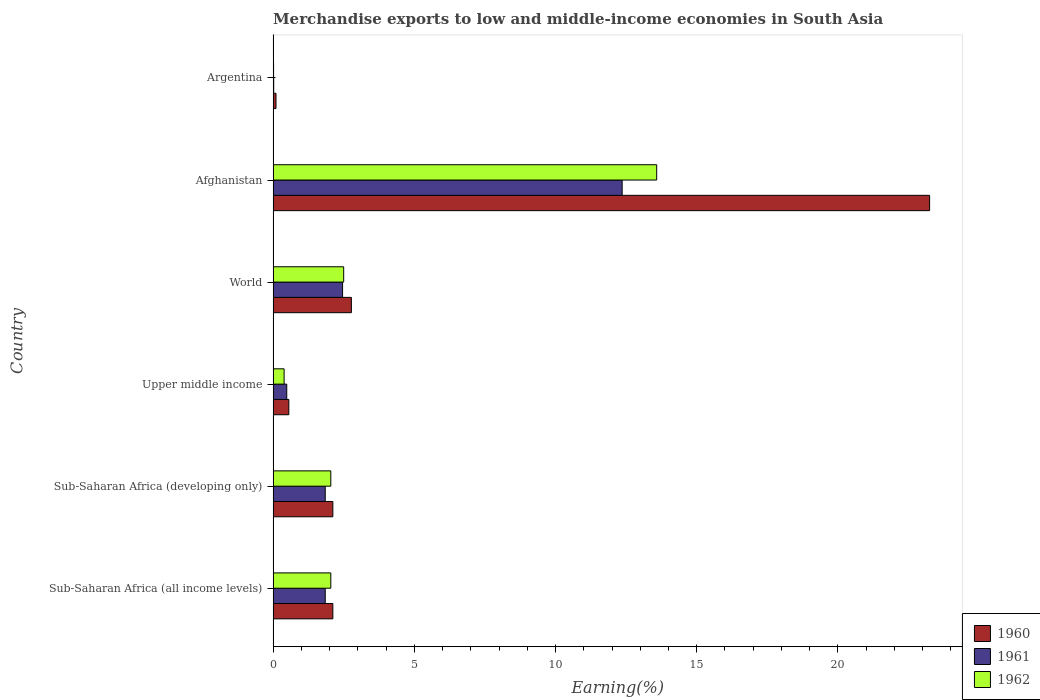How many bars are there on the 6th tick from the bottom?
Give a very brief answer. 3. In how many cases, is the number of bars for a given country not equal to the number of legend labels?
Provide a short and direct response. 0. What is the percentage of amount earned from merchandise exports in 1962 in Afghanistan?
Provide a short and direct response. 13.58. Across all countries, what is the maximum percentage of amount earned from merchandise exports in 1962?
Your answer should be compact. 13.58. Across all countries, what is the minimum percentage of amount earned from merchandise exports in 1961?
Offer a terse response. 0.02. In which country was the percentage of amount earned from merchandise exports in 1962 maximum?
Give a very brief answer. Afghanistan. What is the total percentage of amount earned from merchandise exports in 1961 in the graph?
Provide a short and direct response. 19.01. What is the difference between the percentage of amount earned from merchandise exports in 1960 in Afghanistan and that in Argentina?
Offer a terse response. 23.14. What is the difference between the percentage of amount earned from merchandise exports in 1960 in Upper middle income and the percentage of amount earned from merchandise exports in 1962 in Sub-Saharan Africa (all income levels)?
Provide a succinct answer. -1.49. What is the average percentage of amount earned from merchandise exports in 1961 per country?
Ensure brevity in your answer.  3.17. What is the difference between the percentage of amount earned from merchandise exports in 1960 and percentage of amount earned from merchandise exports in 1961 in Upper middle income?
Give a very brief answer. 0.07. What is the ratio of the percentage of amount earned from merchandise exports in 1962 in Sub-Saharan Africa (developing only) to that in World?
Keep it short and to the point. 0.82. What is the difference between the highest and the second highest percentage of amount earned from merchandise exports in 1961?
Make the answer very short. 9.9. What is the difference between the highest and the lowest percentage of amount earned from merchandise exports in 1961?
Your answer should be compact. 12.34. In how many countries, is the percentage of amount earned from merchandise exports in 1960 greater than the average percentage of amount earned from merchandise exports in 1960 taken over all countries?
Provide a succinct answer. 1. Is the sum of the percentage of amount earned from merchandise exports in 1960 in Upper middle income and World greater than the maximum percentage of amount earned from merchandise exports in 1962 across all countries?
Provide a succinct answer. No. Is it the case that in every country, the sum of the percentage of amount earned from merchandise exports in 1962 and percentage of amount earned from merchandise exports in 1960 is greater than the percentage of amount earned from merchandise exports in 1961?
Offer a very short reply. Yes. Are all the bars in the graph horizontal?
Offer a terse response. Yes. What is the difference between two consecutive major ticks on the X-axis?
Ensure brevity in your answer.  5. Where does the legend appear in the graph?
Keep it short and to the point. Bottom right. How many legend labels are there?
Your answer should be compact. 3. What is the title of the graph?
Offer a very short reply. Merchandise exports to low and middle-income economies in South Asia. What is the label or title of the X-axis?
Offer a very short reply. Earning(%). What is the label or title of the Y-axis?
Your answer should be compact. Country. What is the Earning(%) in 1960 in Sub-Saharan Africa (all income levels)?
Offer a very short reply. 2.11. What is the Earning(%) of 1961 in Sub-Saharan Africa (all income levels)?
Give a very brief answer. 1.85. What is the Earning(%) in 1962 in Sub-Saharan Africa (all income levels)?
Your answer should be very brief. 2.04. What is the Earning(%) of 1960 in Sub-Saharan Africa (developing only)?
Your response must be concise. 2.11. What is the Earning(%) in 1961 in Sub-Saharan Africa (developing only)?
Your answer should be compact. 1.85. What is the Earning(%) of 1962 in Sub-Saharan Africa (developing only)?
Keep it short and to the point. 2.04. What is the Earning(%) in 1960 in Upper middle income?
Provide a short and direct response. 0.56. What is the Earning(%) in 1961 in Upper middle income?
Make the answer very short. 0.48. What is the Earning(%) in 1962 in Upper middle income?
Offer a very short reply. 0.39. What is the Earning(%) of 1960 in World?
Ensure brevity in your answer.  2.77. What is the Earning(%) of 1961 in World?
Keep it short and to the point. 2.46. What is the Earning(%) of 1962 in World?
Your response must be concise. 2.5. What is the Earning(%) in 1960 in Afghanistan?
Your answer should be very brief. 23.25. What is the Earning(%) of 1961 in Afghanistan?
Your answer should be very brief. 12.36. What is the Earning(%) in 1962 in Afghanistan?
Ensure brevity in your answer.  13.58. What is the Earning(%) of 1960 in Argentina?
Your answer should be very brief. 0.1. What is the Earning(%) of 1961 in Argentina?
Provide a short and direct response. 0.02. What is the Earning(%) of 1962 in Argentina?
Ensure brevity in your answer.  0.02. Across all countries, what is the maximum Earning(%) of 1960?
Your response must be concise. 23.25. Across all countries, what is the maximum Earning(%) in 1961?
Your answer should be compact. 12.36. Across all countries, what is the maximum Earning(%) in 1962?
Offer a terse response. 13.58. Across all countries, what is the minimum Earning(%) of 1960?
Provide a short and direct response. 0.1. Across all countries, what is the minimum Earning(%) of 1961?
Provide a short and direct response. 0.02. Across all countries, what is the minimum Earning(%) of 1962?
Provide a succinct answer. 0.02. What is the total Earning(%) in 1960 in the graph?
Provide a short and direct response. 30.91. What is the total Earning(%) in 1961 in the graph?
Provide a succinct answer. 19.01. What is the total Earning(%) in 1962 in the graph?
Your answer should be compact. 20.57. What is the difference between the Earning(%) in 1960 in Sub-Saharan Africa (all income levels) and that in Upper middle income?
Provide a short and direct response. 1.56. What is the difference between the Earning(%) of 1961 in Sub-Saharan Africa (all income levels) and that in Upper middle income?
Your answer should be very brief. 1.36. What is the difference between the Earning(%) in 1962 in Sub-Saharan Africa (all income levels) and that in Upper middle income?
Offer a very short reply. 1.65. What is the difference between the Earning(%) in 1960 in Sub-Saharan Africa (all income levels) and that in World?
Make the answer very short. -0.66. What is the difference between the Earning(%) in 1961 in Sub-Saharan Africa (all income levels) and that in World?
Your response must be concise. -0.61. What is the difference between the Earning(%) in 1962 in Sub-Saharan Africa (all income levels) and that in World?
Give a very brief answer. -0.46. What is the difference between the Earning(%) in 1960 in Sub-Saharan Africa (all income levels) and that in Afghanistan?
Give a very brief answer. -21.13. What is the difference between the Earning(%) in 1961 in Sub-Saharan Africa (all income levels) and that in Afghanistan?
Make the answer very short. -10.51. What is the difference between the Earning(%) of 1962 in Sub-Saharan Africa (all income levels) and that in Afghanistan?
Offer a very short reply. -11.54. What is the difference between the Earning(%) in 1960 in Sub-Saharan Africa (all income levels) and that in Argentina?
Your answer should be compact. 2.01. What is the difference between the Earning(%) of 1961 in Sub-Saharan Africa (all income levels) and that in Argentina?
Ensure brevity in your answer.  1.82. What is the difference between the Earning(%) in 1962 in Sub-Saharan Africa (all income levels) and that in Argentina?
Offer a terse response. 2.03. What is the difference between the Earning(%) of 1960 in Sub-Saharan Africa (developing only) and that in Upper middle income?
Offer a terse response. 1.56. What is the difference between the Earning(%) of 1961 in Sub-Saharan Africa (developing only) and that in Upper middle income?
Keep it short and to the point. 1.36. What is the difference between the Earning(%) of 1962 in Sub-Saharan Africa (developing only) and that in Upper middle income?
Provide a short and direct response. 1.65. What is the difference between the Earning(%) of 1960 in Sub-Saharan Africa (developing only) and that in World?
Provide a succinct answer. -0.66. What is the difference between the Earning(%) of 1961 in Sub-Saharan Africa (developing only) and that in World?
Give a very brief answer. -0.61. What is the difference between the Earning(%) of 1962 in Sub-Saharan Africa (developing only) and that in World?
Your answer should be compact. -0.46. What is the difference between the Earning(%) in 1960 in Sub-Saharan Africa (developing only) and that in Afghanistan?
Offer a very short reply. -21.13. What is the difference between the Earning(%) of 1961 in Sub-Saharan Africa (developing only) and that in Afghanistan?
Your response must be concise. -10.51. What is the difference between the Earning(%) of 1962 in Sub-Saharan Africa (developing only) and that in Afghanistan?
Provide a succinct answer. -11.54. What is the difference between the Earning(%) in 1960 in Sub-Saharan Africa (developing only) and that in Argentina?
Offer a terse response. 2.01. What is the difference between the Earning(%) of 1961 in Sub-Saharan Africa (developing only) and that in Argentina?
Your answer should be very brief. 1.82. What is the difference between the Earning(%) in 1962 in Sub-Saharan Africa (developing only) and that in Argentina?
Offer a very short reply. 2.03. What is the difference between the Earning(%) in 1960 in Upper middle income and that in World?
Your answer should be compact. -2.21. What is the difference between the Earning(%) in 1961 in Upper middle income and that in World?
Your response must be concise. -1.98. What is the difference between the Earning(%) in 1962 in Upper middle income and that in World?
Your answer should be compact. -2.11. What is the difference between the Earning(%) of 1960 in Upper middle income and that in Afghanistan?
Give a very brief answer. -22.69. What is the difference between the Earning(%) of 1961 in Upper middle income and that in Afghanistan?
Provide a short and direct response. -11.88. What is the difference between the Earning(%) in 1962 in Upper middle income and that in Afghanistan?
Provide a short and direct response. -13.19. What is the difference between the Earning(%) in 1960 in Upper middle income and that in Argentina?
Your answer should be very brief. 0.45. What is the difference between the Earning(%) in 1961 in Upper middle income and that in Argentina?
Make the answer very short. 0.46. What is the difference between the Earning(%) in 1962 in Upper middle income and that in Argentina?
Offer a terse response. 0.37. What is the difference between the Earning(%) in 1960 in World and that in Afghanistan?
Your answer should be very brief. -20.48. What is the difference between the Earning(%) in 1961 in World and that in Afghanistan?
Give a very brief answer. -9.9. What is the difference between the Earning(%) of 1962 in World and that in Afghanistan?
Your answer should be compact. -11.08. What is the difference between the Earning(%) in 1960 in World and that in Argentina?
Offer a very short reply. 2.67. What is the difference between the Earning(%) of 1961 in World and that in Argentina?
Your response must be concise. 2.44. What is the difference between the Earning(%) in 1962 in World and that in Argentina?
Make the answer very short. 2.48. What is the difference between the Earning(%) in 1960 in Afghanistan and that in Argentina?
Make the answer very short. 23.14. What is the difference between the Earning(%) in 1961 in Afghanistan and that in Argentina?
Your answer should be compact. 12.34. What is the difference between the Earning(%) in 1962 in Afghanistan and that in Argentina?
Your response must be concise. 13.57. What is the difference between the Earning(%) in 1960 in Sub-Saharan Africa (all income levels) and the Earning(%) in 1961 in Sub-Saharan Africa (developing only)?
Provide a short and direct response. 0.27. What is the difference between the Earning(%) in 1960 in Sub-Saharan Africa (all income levels) and the Earning(%) in 1962 in Sub-Saharan Africa (developing only)?
Keep it short and to the point. 0.07. What is the difference between the Earning(%) in 1961 in Sub-Saharan Africa (all income levels) and the Earning(%) in 1962 in Sub-Saharan Africa (developing only)?
Provide a succinct answer. -0.2. What is the difference between the Earning(%) in 1960 in Sub-Saharan Africa (all income levels) and the Earning(%) in 1961 in Upper middle income?
Your answer should be very brief. 1.63. What is the difference between the Earning(%) in 1960 in Sub-Saharan Africa (all income levels) and the Earning(%) in 1962 in Upper middle income?
Offer a very short reply. 1.73. What is the difference between the Earning(%) of 1961 in Sub-Saharan Africa (all income levels) and the Earning(%) of 1962 in Upper middle income?
Offer a terse response. 1.46. What is the difference between the Earning(%) in 1960 in Sub-Saharan Africa (all income levels) and the Earning(%) in 1961 in World?
Provide a succinct answer. -0.34. What is the difference between the Earning(%) of 1960 in Sub-Saharan Africa (all income levels) and the Earning(%) of 1962 in World?
Provide a short and direct response. -0.38. What is the difference between the Earning(%) of 1961 in Sub-Saharan Africa (all income levels) and the Earning(%) of 1962 in World?
Give a very brief answer. -0.65. What is the difference between the Earning(%) in 1960 in Sub-Saharan Africa (all income levels) and the Earning(%) in 1961 in Afghanistan?
Make the answer very short. -10.24. What is the difference between the Earning(%) in 1960 in Sub-Saharan Africa (all income levels) and the Earning(%) in 1962 in Afghanistan?
Make the answer very short. -11.47. What is the difference between the Earning(%) in 1961 in Sub-Saharan Africa (all income levels) and the Earning(%) in 1962 in Afghanistan?
Provide a short and direct response. -11.74. What is the difference between the Earning(%) in 1960 in Sub-Saharan Africa (all income levels) and the Earning(%) in 1961 in Argentina?
Provide a succinct answer. 2.09. What is the difference between the Earning(%) in 1960 in Sub-Saharan Africa (all income levels) and the Earning(%) in 1962 in Argentina?
Make the answer very short. 2.1. What is the difference between the Earning(%) in 1961 in Sub-Saharan Africa (all income levels) and the Earning(%) in 1962 in Argentina?
Provide a succinct answer. 1.83. What is the difference between the Earning(%) of 1960 in Sub-Saharan Africa (developing only) and the Earning(%) of 1961 in Upper middle income?
Offer a terse response. 1.63. What is the difference between the Earning(%) in 1960 in Sub-Saharan Africa (developing only) and the Earning(%) in 1962 in Upper middle income?
Provide a succinct answer. 1.73. What is the difference between the Earning(%) of 1961 in Sub-Saharan Africa (developing only) and the Earning(%) of 1962 in Upper middle income?
Your response must be concise. 1.46. What is the difference between the Earning(%) of 1960 in Sub-Saharan Africa (developing only) and the Earning(%) of 1961 in World?
Offer a terse response. -0.34. What is the difference between the Earning(%) in 1960 in Sub-Saharan Africa (developing only) and the Earning(%) in 1962 in World?
Ensure brevity in your answer.  -0.38. What is the difference between the Earning(%) of 1961 in Sub-Saharan Africa (developing only) and the Earning(%) of 1962 in World?
Give a very brief answer. -0.65. What is the difference between the Earning(%) of 1960 in Sub-Saharan Africa (developing only) and the Earning(%) of 1961 in Afghanistan?
Ensure brevity in your answer.  -10.24. What is the difference between the Earning(%) in 1960 in Sub-Saharan Africa (developing only) and the Earning(%) in 1962 in Afghanistan?
Give a very brief answer. -11.47. What is the difference between the Earning(%) in 1961 in Sub-Saharan Africa (developing only) and the Earning(%) in 1962 in Afghanistan?
Ensure brevity in your answer.  -11.74. What is the difference between the Earning(%) of 1960 in Sub-Saharan Africa (developing only) and the Earning(%) of 1961 in Argentina?
Make the answer very short. 2.09. What is the difference between the Earning(%) of 1960 in Sub-Saharan Africa (developing only) and the Earning(%) of 1962 in Argentina?
Make the answer very short. 2.1. What is the difference between the Earning(%) in 1961 in Sub-Saharan Africa (developing only) and the Earning(%) in 1962 in Argentina?
Ensure brevity in your answer.  1.83. What is the difference between the Earning(%) of 1960 in Upper middle income and the Earning(%) of 1961 in World?
Your answer should be very brief. -1.9. What is the difference between the Earning(%) of 1960 in Upper middle income and the Earning(%) of 1962 in World?
Ensure brevity in your answer.  -1.94. What is the difference between the Earning(%) in 1961 in Upper middle income and the Earning(%) in 1962 in World?
Provide a succinct answer. -2.02. What is the difference between the Earning(%) in 1960 in Upper middle income and the Earning(%) in 1961 in Afghanistan?
Your answer should be compact. -11.8. What is the difference between the Earning(%) in 1960 in Upper middle income and the Earning(%) in 1962 in Afghanistan?
Keep it short and to the point. -13.03. What is the difference between the Earning(%) in 1961 in Upper middle income and the Earning(%) in 1962 in Afghanistan?
Provide a short and direct response. -13.1. What is the difference between the Earning(%) of 1960 in Upper middle income and the Earning(%) of 1961 in Argentina?
Make the answer very short. 0.54. What is the difference between the Earning(%) in 1960 in Upper middle income and the Earning(%) in 1962 in Argentina?
Ensure brevity in your answer.  0.54. What is the difference between the Earning(%) of 1961 in Upper middle income and the Earning(%) of 1962 in Argentina?
Your answer should be compact. 0.47. What is the difference between the Earning(%) in 1960 in World and the Earning(%) in 1961 in Afghanistan?
Provide a succinct answer. -9.59. What is the difference between the Earning(%) in 1960 in World and the Earning(%) in 1962 in Afghanistan?
Your answer should be compact. -10.81. What is the difference between the Earning(%) in 1961 in World and the Earning(%) in 1962 in Afghanistan?
Ensure brevity in your answer.  -11.12. What is the difference between the Earning(%) of 1960 in World and the Earning(%) of 1961 in Argentina?
Your answer should be very brief. 2.75. What is the difference between the Earning(%) in 1960 in World and the Earning(%) in 1962 in Argentina?
Your answer should be compact. 2.75. What is the difference between the Earning(%) of 1961 in World and the Earning(%) of 1962 in Argentina?
Provide a succinct answer. 2.44. What is the difference between the Earning(%) of 1960 in Afghanistan and the Earning(%) of 1961 in Argentina?
Keep it short and to the point. 23.23. What is the difference between the Earning(%) of 1960 in Afghanistan and the Earning(%) of 1962 in Argentina?
Your answer should be compact. 23.23. What is the difference between the Earning(%) in 1961 in Afghanistan and the Earning(%) in 1962 in Argentina?
Your answer should be compact. 12.34. What is the average Earning(%) of 1960 per country?
Keep it short and to the point. 5.15. What is the average Earning(%) of 1961 per country?
Offer a terse response. 3.17. What is the average Earning(%) in 1962 per country?
Provide a succinct answer. 3.43. What is the difference between the Earning(%) in 1960 and Earning(%) in 1961 in Sub-Saharan Africa (all income levels)?
Your answer should be very brief. 0.27. What is the difference between the Earning(%) in 1960 and Earning(%) in 1962 in Sub-Saharan Africa (all income levels)?
Offer a very short reply. 0.07. What is the difference between the Earning(%) in 1961 and Earning(%) in 1962 in Sub-Saharan Africa (all income levels)?
Offer a very short reply. -0.2. What is the difference between the Earning(%) in 1960 and Earning(%) in 1961 in Sub-Saharan Africa (developing only)?
Provide a succinct answer. 0.27. What is the difference between the Earning(%) in 1960 and Earning(%) in 1962 in Sub-Saharan Africa (developing only)?
Provide a short and direct response. 0.07. What is the difference between the Earning(%) in 1961 and Earning(%) in 1962 in Sub-Saharan Africa (developing only)?
Offer a terse response. -0.2. What is the difference between the Earning(%) in 1960 and Earning(%) in 1961 in Upper middle income?
Your response must be concise. 0.07. What is the difference between the Earning(%) of 1960 and Earning(%) of 1962 in Upper middle income?
Keep it short and to the point. 0.17. What is the difference between the Earning(%) of 1961 and Earning(%) of 1962 in Upper middle income?
Your answer should be very brief. 0.09. What is the difference between the Earning(%) in 1960 and Earning(%) in 1961 in World?
Your answer should be compact. 0.31. What is the difference between the Earning(%) in 1960 and Earning(%) in 1962 in World?
Ensure brevity in your answer.  0.27. What is the difference between the Earning(%) of 1961 and Earning(%) of 1962 in World?
Give a very brief answer. -0.04. What is the difference between the Earning(%) in 1960 and Earning(%) in 1961 in Afghanistan?
Provide a succinct answer. 10.89. What is the difference between the Earning(%) in 1960 and Earning(%) in 1962 in Afghanistan?
Make the answer very short. 9.66. What is the difference between the Earning(%) of 1961 and Earning(%) of 1962 in Afghanistan?
Provide a succinct answer. -1.22. What is the difference between the Earning(%) in 1960 and Earning(%) in 1961 in Argentina?
Ensure brevity in your answer.  0.08. What is the difference between the Earning(%) in 1960 and Earning(%) in 1962 in Argentina?
Provide a succinct answer. 0.09. What is the difference between the Earning(%) in 1961 and Earning(%) in 1962 in Argentina?
Provide a succinct answer. 0. What is the ratio of the Earning(%) of 1962 in Sub-Saharan Africa (all income levels) to that in Sub-Saharan Africa (developing only)?
Provide a succinct answer. 1. What is the ratio of the Earning(%) of 1960 in Sub-Saharan Africa (all income levels) to that in Upper middle income?
Your response must be concise. 3.8. What is the ratio of the Earning(%) in 1961 in Sub-Saharan Africa (all income levels) to that in Upper middle income?
Offer a terse response. 3.82. What is the ratio of the Earning(%) of 1962 in Sub-Saharan Africa (all income levels) to that in Upper middle income?
Your response must be concise. 5.25. What is the ratio of the Earning(%) in 1960 in Sub-Saharan Africa (all income levels) to that in World?
Make the answer very short. 0.76. What is the ratio of the Earning(%) in 1961 in Sub-Saharan Africa (all income levels) to that in World?
Your response must be concise. 0.75. What is the ratio of the Earning(%) of 1962 in Sub-Saharan Africa (all income levels) to that in World?
Provide a short and direct response. 0.82. What is the ratio of the Earning(%) of 1960 in Sub-Saharan Africa (all income levels) to that in Afghanistan?
Provide a short and direct response. 0.09. What is the ratio of the Earning(%) in 1961 in Sub-Saharan Africa (all income levels) to that in Afghanistan?
Keep it short and to the point. 0.15. What is the ratio of the Earning(%) in 1962 in Sub-Saharan Africa (all income levels) to that in Afghanistan?
Your response must be concise. 0.15. What is the ratio of the Earning(%) of 1960 in Sub-Saharan Africa (all income levels) to that in Argentina?
Your response must be concise. 20.75. What is the ratio of the Earning(%) of 1961 in Sub-Saharan Africa (all income levels) to that in Argentina?
Keep it short and to the point. 88.95. What is the ratio of the Earning(%) in 1962 in Sub-Saharan Africa (all income levels) to that in Argentina?
Your answer should be compact. 124.28. What is the ratio of the Earning(%) of 1960 in Sub-Saharan Africa (developing only) to that in Upper middle income?
Provide a succinct answer. 3.8. What is the ratio of the Earning(%) of 1961 in Sub-Saharan Africa (developing only) to that in Upper middle income?
Your response must be concise. 3.82. What is the ratio of the Earning(%) in 1962 in Sub-Saharan Africa (developing only) to that in Upper middle income?
Provide a short and direct response. 5.25. What is the ratio of the Earning(%) of 1960 in Sub-Saharan Africa (developing only) to that in World?
Your answer should be very brief. 0.76. What is the ratio of the Earning(%) in 1961 in Sub-Saharan Africa (developing only) to that in World?
Provide a succinct answer. 0.75. What is the ratio of the Earning(%) of 1962 in Sub-Saharan Africa (developing only) to that in World?
Make the answer very short. 0.82. What is the ratio of the Earning(%) of 1960 in Sub-Saharan Africa (developing only) to that in Afghanistan?
Offer a very short reply. 0.09. What is the ratio of the Earning(%) in 1961 in Sub-Saharan Africa (developing only) to that in Afghanistan?
Ensure brevity in your answer.  0.15. What is the ratio of the Earning(%) in 1962 in Sub-Saharan Africa (developing only) to that in Afghanistan?
Provide a short and direct response. 0.15. What is the ratio of the Earning(%) in 1960 in Sub-Saharan Africa (developing only) to that in Argentina?
Your answer should be compact. 20.75. What is the ratio of the Earning(%) in 1961 in Sub-Saharan Africa (developing only) to that in Argentina?
Your response must be concise. 88.95. What is the ratio of the Earning(%) in 1962 in Sub-Saharan Africa (developing only) to that in Argentina?
Keep it short and to the point. 124.28. What is the ratio of the Earning(%) in 1960 in Upper middle income to that in World?
Provide a short and direct response. 0.2. What is the ratio of the Earning(%) of 1961 in Upper middle income to that in World?
Make the answer very short. 0.2. What is the ratio of the Earning(%) of 1962 in Upper middle income to that in World?
Keep it short and to the point. 0.16. What is the ratio of the Earning(%) in 1960 in Upper middle income to that in Afghanistan?
Provide a succinct answer. 0.02. What is the ratio of the Earning(%) of 1961 in Upper middle income to that in Afghanistan?
Ensure brevity in your answer.  0.04. What is the ratio of the Earning(%) of 1962 in Upper middle income to that in Afghanistan?
Your answer should be very brief. 0.03. What is the ratio of the Earning(%) of 1960 in Upper middle income to that in Argentina?
Your answer should be very brief. 5.46. What is the ratio of the Earning(%) of 1961 in Upper middle income to that in Argentina?
Your answer should be compact. 23.27. What is the ratio of the Earning(%) of 1962 in Upper middle income to that in Argentina?
Your answer should be very brief. 23.68. What is the ratio of the Earning(%) in 1960 in World to that in Afghanistan?
Offer a terse response. 0.12. What is the ratio of the Earning(%) of 1961 in World to that in Afghanistan?
Make the answer very short. 0.2. What is the ratio of the Earning(%) of 1962 in World to that in Afghanistan?
Your response must be concise. 0.18. What is the ratio of the Earning(%) of 1960 in World to that in Argentina?
Give a very brief answer. 27.18. What is the ratio of the Earning(%) in 1961 in World to that in Argentina?
Make the answer very short. 118.57. What is the ratio of the Earning(%) of 1962 in World to that in Argentina?
Offer a terse response. 152.02. What is the ratio of the Earning(%) in 1960 in Afghanistan to that in Argentina?
Make the answer very short. 228.05. What is the ratio of the Earning(%) in 1961 in Afghanistan to that in Argentina?
Your answer should be compact. 595.85. What is the ratio of the Earning(%) of 1962 in Afghanistan to that in Argentina?
Give a very brief answer. 826.35. What is the difference between the highest and the second highest Earning(%) of 1960?
Ensure brevity in your answer.  20.48. What is the difference between the highest and the second highest Earning(%) in 1961?
Offer a terse response. 9.9. What is the difference between the highest and the second highest Earning(%) of 1962?
Ensure brevity in your answer.  11.08. What is the difference between the highest and the lowest Earning(%) of 1960?
Provide a succinct answer. 23.14. What is the difference between the highest and the lowest Earning(%) in 1961?
Provide a short and direct response. 12.34. What is the difference between the highest and the lowest Earning(%) of 1962?
Ensure brevity in your answer.  13.57. 